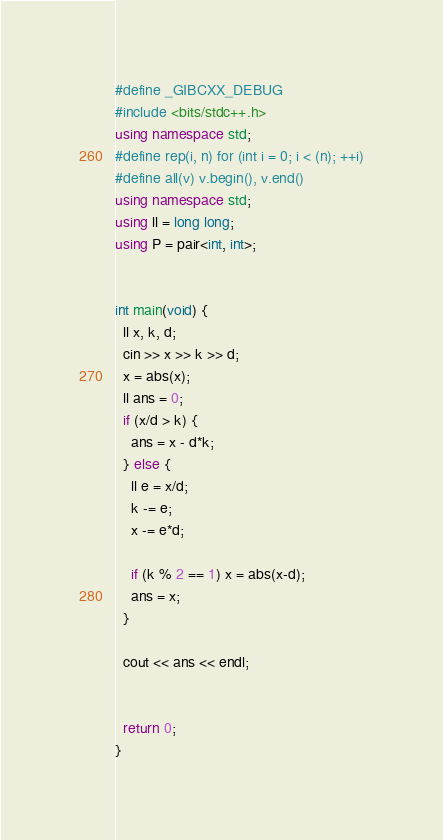<code> <loc_0><loc_0><loc_500><loc_500><_C++_>#define _GIBCXX_DEBUG
#include <bits/stdc++.h>
using namespace std;
#define rep(i, n) for (int i = 0; i < (n); ++i)
#define all(v) v.begin(), v.end()
using namespace std;
using ll = long long;
using P = pair<int, int>;


int main(void) {
  ll x, k, d;
  cin >> x >> k >> d;
  x = abs(x);
  ll ans = 0;
  if (x/d > k) {
    ans = x - d*k;
  } else {
    ll e = x/d;
    k -= e;
    x -= e*d;

    if (k % 2 == 1) x = abs(x-d);
    ans = x;
  }

  cout << ans << endl;

  
  return 0;
}</code> 